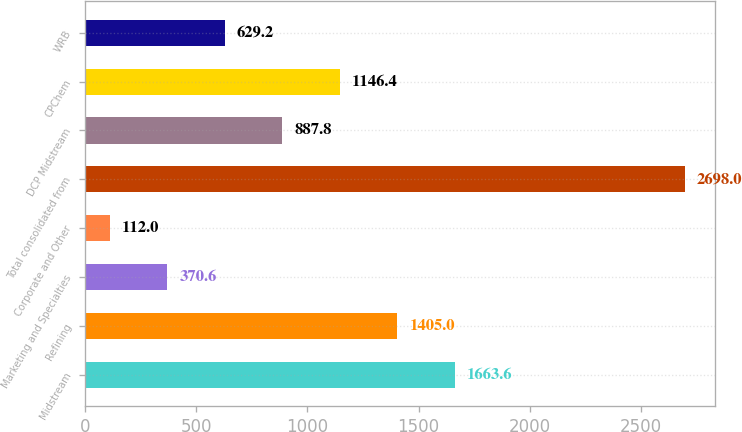Convert chart to OTSL. <chart><loc_0><loc_0><loc_500><loc_500><bar_chart><fcel>Midstream<fcel>Refining<fcel>Marketing and Specialties<fcel>Corporate and Other<fcel>Total consolidated from<fcel>DCP Midstream<fcel>CPChem<fcel>WRB<nl><fcel>1663.6<fcel>1405<fcel>370.6<fcel>112<fcel>2698<fcel>887.8<fcel>1146.4<fcel>629.2<nl></chart> 